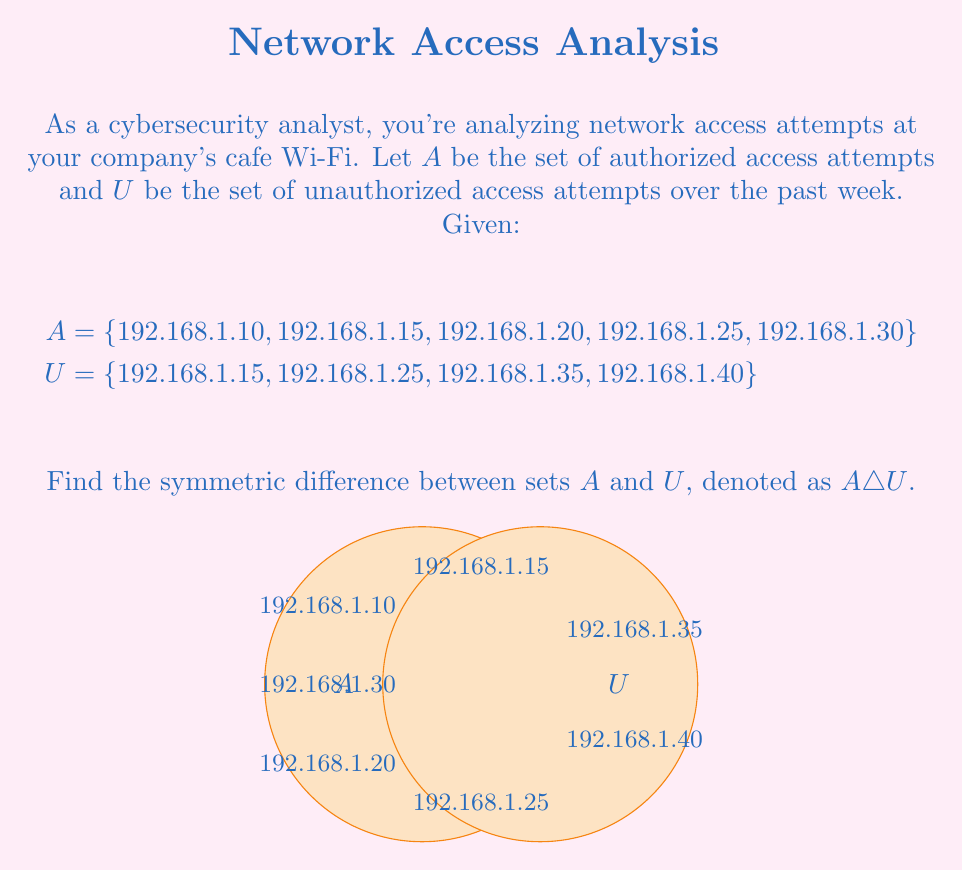Provide a solution to this math problem. To find the symmetric difference between sets A and U, we need to follow these steps:

1) The symmetric difference $A \triangle U$ is defined as the set of elements that are in either A or U, but not in both. It can be expressed as:

   $A \triangle U = (A \cup U) \setminus (A \cap U)$

2) First, let's find $A \cup U$:
   $A \cup U = \{192.168.1.10, 192.168.1.15, 192.168.1.20, 192.168.1.25, 192.168.1.30, 192.168.1.35, 192.168.1.40\}$

3) Next, let's find $A \cap U$:
   $A \cap U = \{192.168.1.15, 192.168.1.25\}$

4) Now, we can find $A \triangle U$ by removing the elements of $A \cap U$ from $A \cup U$:

   $A \triangle U = \{192.168.1.10, 192.168.1.20, 192.168.1.30, 192.168.1.35, 192.168.1.40\}$

5) Alternatively, we could have used the fact that:
   $A \triangle U = (A \setminus U) \cup (U \setminus A)$

   Where:
   $A \setminus U = \{192.168.1.10, 192.168.1.20, 192.168.1.30\}$
   $U \setminus A = \{192.168.1.35, 192.168.1.40\}$

   This gives us the same result:
   $A \triangle U = \{192.168.1.10, 192.168.1.20, 192.168.1.30, 192.168.1.35, 192.168.1.40\}$
Answer: $\{192.168.1.10, 192.168.1.20, 192.168.1.30, 192.168.1.35, 192.168.1.40\}$ 